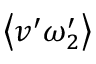Convert formula to latex. <formula><loc_0><loc_0><loc_500><loc_500>\left \langle v ^ { \prime } \omega _ { 2 } ^ { \prime } \right \rangle</formula> 